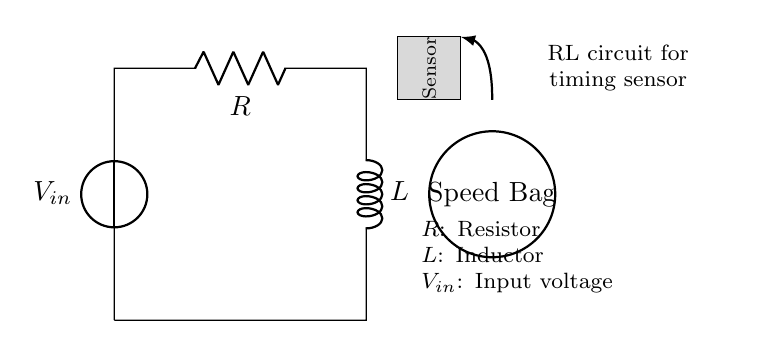What is the input voltage in this circuit? The input voltage is represented as \(V_{in}\) in the circuit diagram, indicating it is the voltage supplied to the circuit.
Answer: \(V_{in}\) What are the components in this RL circuit? The circuit consists of a resistor and an inductor, indicated by the symbols \(R\) and \(L\) respectively, as seen in the diagram.
Answer: Resistor and Inductor What symbol represents the inductor in the circuit? The inductor is represented by the letter \(L\) with a coiled line in the circuit diagram, which is a standard symbol for inductors.
Answer: L How does the sensor relate to the speed bag? The sensor is positioned directly above the speed bag and connects to the circuit, indicating its role in detecting the movement of the bag.
Answer: Detects movement What is the purpose of the resistor in this RL circuit? The resistor limits the current flow in the circuit, affecting the timing characteristics of the RL circuit necessary for the sensor operation with the speed bag.
Answer: Limit current flow What happens to the current when the speed bag is hit? When the speed bag is hit, the sensor detects a change, causing a transient response in the RL circuit, which will affect the current flow through the inductor.
Answer: Causes transient response How do the resistor and inductor affect the timing of the circuit? The resistor and inductor together create a time constant (\(\tau = \frac{L}{R}\)), determining how fast the circuit responds to changes in the input, which is critical for timing in boxing training.
Answer: Create time constant 